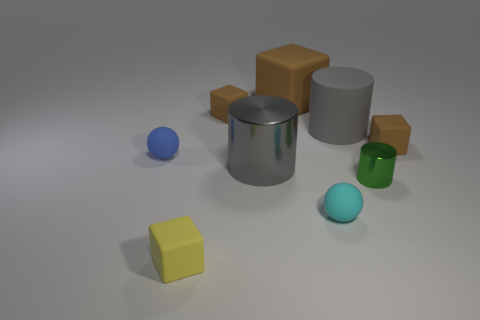How many brown blocks must be subtracted to get 1 brown blocks? 2 Subtract all brown cylinders. How many brown blocks are left? 3 Subtract 1 blocks. How many blocks are left? 3 Add 1 matte cylinders. How many objects exist? 10 Subtract all blocks. How many objects are left? 5 Add 9 tiny purple rubber spheres. How many tiny purple rubber spheres exist? 9 Subtract 0 purple blocks. How many objects are left? 9 Subtract all big brown cubes. Subtract all tiny green shiny cylinders. How many objects are left? 7 Add 1 small brown things. How many small brown things are left? 3 